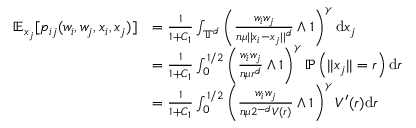<formula> <loc_0><loc_0><loc_500><loc_500>\begin{array} { r l } { \mathbb { E } _ { x _ { j } } [ p _ { i j } ( w _ { i } , w _ { j } , x _ { i } , x _ { j } ) ] } & { = \frac { 1 } { 1 + C _ { 1 } } \int _ { \mathbb { T } ^ { d } } \left ( \frac { w _ { i } w _ { j } } { n \mu | | x _ { i } - x _ { j } | | ^ { d } } \wedge 1 \right ) ^ { \gamma } d x _ { j } } \\ & { = \frac { 1 } { 1 + C _ { 1 } } \int _ { 0 } ^ { 1 / 2 } \left ( \frac { w _ { i } w _ { j } } { n \mu r ^ { d } } \wedge 1 \right ) ^ { \gamma } \mathbb { P } \left ( | | x _ { j } | | = r \right ) d r } \\ & { = \frac { 1 } { 1 + C _ { 1 } } \int _ { 0 } ^ { 1 / 2 } \left ( \frac { w _ { i } w _ { j } } { n \mu 2 ^ { - d } V ( r ) } \wedge 1 \right ) ^ { \gamma } V ^ { \prime } ( r ) d r } \end{array}</formula> 